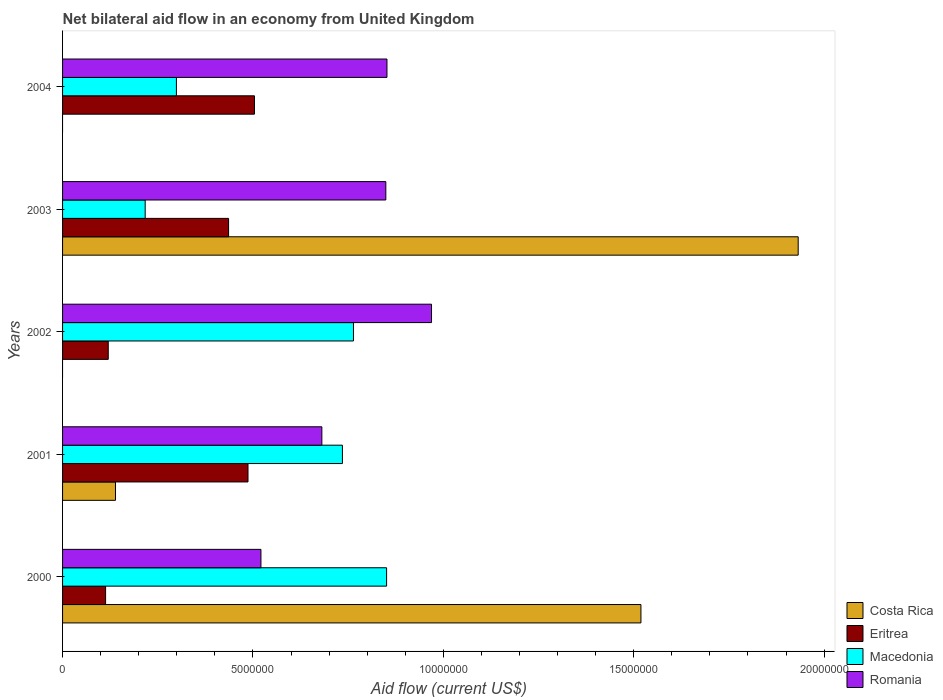How many different coloured bars are there?
Provide a succinct answer. 4. What is the net bilateral aid flow in Macedonia in 2000?
Your answer should be very brief. 8.51e+06. Across all years, what is the maximum net bilateral aid flow in Romania?
Your answer should be compact. 9.69e+06. Across all years, what is the minimum net bilateral aid flow in Eritrea?
Your response must be concise. 1.13e+06. What is the total net bilateral aid flow in Costa Rica in the graph?
Give a very brief answer. 3.59e+07. What is the difference between the net bilateral aid flow in Eritrea in 2002 and that in 2004?
Offer a very short reply. -3.84e+06. What is the difference between the net bilateral aid flow in Costa Rica in 2004 and the net bilateral aid flow in Macedonia in 2003?
Give a very brief answer. -2.17e+06. What is the average net bilateral aid flow in Macedonia per year?
Make the answer very short. 5.73e+06. In the year 2001, what is the difference between the net bilateral aid flow in Costa Rica and net bilateral aid flow in Eritrea?
Offer a very short reply. -3.48e+06. In how many years, is the net bilateral aid flow in Costa Rica greater than 16000000 US$?
Offer a very short reply. 1. What is the ratio of the net bilateral aid flow in Eritrea in 2000 to that in 2002?
Offer a terse response. 0.94. Is the difference between the net bilateral aid flow in Costa Rica in 2001 and 2003 greater than the difference between the net bilateral aid flow in Eritrea in 2001 and 2003?
Provide a succinct answer. No. What is the difference between the highest and the second highest net bilateral aid flow in Costa Rica?
Provide a succinct answer. 4.13e+06. What is the difference between the highest and the lowest net bilateral aid flow in Macedonia?
Your answer should be very brief. 6.34e+06. Is the sum of the net bilateral aid flow in Macedonia in 2002 and 2003 greater than the maximum net bilateral aid flow in Romania across all years?
Offer a terse response. Yes. Is it the case that in every year, the sum of the net bilateral aid flow in Costa Rica and net bilateral aid flow in Eritrea is greater than the sum of net bilateral aid flow in Macedonia and net bilateral aid flow in Romania?
Your answer should be very brief. No. Is it the case that in every year, the sum of the net bilateral aid flow in Romania and net bilateral aid flow in Costa Rica is greater than the net bilateral aid flow in Eritrea?
Your answer should be very brief. Yes. How many bars are there?
Make the answer very short. 18. How many years are there in the graph?
Your response must be concise. 5. Are the values on the major ticks of X-axis written in scientific E-notation?
Offer a terse response. No. Does the graph contain any zero values?
Ensure brevity in your answer.  Yes. Does the graph contain grids?
Provide a short and direct response. No. Where does the legend appear in the graph?
Make the answer very short. Bottom right. How many legend labels are there?
Make the answer very short. 4. How are the legend labels stacked?
Provide a succinct answer. Vertical. What is the title of the graph?
Give a very brief answer. Net bilateral aid flow in an economy from United Kingdom. Does "Senegal" appear as one of the legend labels in the graph?
Make the answer very short. No. What is the label or title of the X-axis?
Provide a short and direct response. Aid flow (current US$). What is the Aid flow (current US$) in Costa Rica in 2000?
Ensure brevity in your answer.  1.52e+07. What is the Aid flow (current US$) in Eritrea in 2000?
Your answer should be very brief. 1.13e+06. What is the Aid flow (current US$) in Macedonia in 2000?
Make the answer very short. 8.51e+06. What is the Aid flow (current US$) in Romania in 2000?
Ensure brevity in your answer.  5.21e+06. What is the Aid flow (current US$) of Costa Rica in 2001?
Ensure brevity in your answer.  1.39e+06. What is the Aid flow (current US$) in Eritrea in 2001?
Offer a very short reply. 4.87e+06. What is the Aid flow (current US$) of Macedonia in 2001?
Ensure brevity in your answer.  7.35e+06. What is the Aid flow (current US$) in Romania in 2001?
Offer a very short reply. 6.81e+06. What is the Aid flow (current US$) of Eritrea in 2002?
Give a very brief answer. 1.20e+06. What is the Aid flow (current US$) in Macedonia in 2002?
Your answer should be compact. 7.64e+06. What is the Aid flow (current US$) of Romania in 2002?
Make the answer very short. 9.69e+06. What is the Aid flow (current US$) in Costa Rica in 2003?
Keep it short and to the point. 1.93e+07. What is the Aid flow (current US$) of Eritrea in 2003?
Offer a terse response. 4.36e+06. What is the Aid flow (current US$) of Macedonia in 2003?
Your response must be concise. 2.17e+06. What is the Aid flow (current US$) of Romania in 2003?
Provide a succinct answer. 8.49e+06. What is the Aid flow (current US$) of Costa Rica in 2004?
Provide a succinct answer. 0. What is the Aid flow (current US$) of Eritrea in 2004?
Offer a very short reply. 5.04e+06. What is the Aid flow (current US$) of Macedonia in 2004?
Make the answer very short. 2.99e+06. What is the Aid flow (current US$) in Romania in 2004?
Provide a short and direct response. 8.52e+06. Across all years, what is the maximum Aid flow (current US$) in Costa Rica?
Offer a terse response. 1.93e+07. Across all years, what is the maximum Aid flow (current US$) of Eritrea?
Give a very brief answer. 5.04e+06. Across all years, what is the maximum Aid flow (current US$) in Macedonia?
Your answer should be very brief. 8.51e+06. Across all years, what is the maximum Aid flow (current US$) in Romania?
Offer a very short reply. 9.69e+06. Across all years, what is the minimum Aid flow (current US$) in Costa Rica?
Offer a terse response. 0. Across all years, what is the minimum Aid flow (current US$) of Eritrea?
Make the answer very short. 1.13e+06. Across all years, what is the minimum Aid flow (current US$) of Macedonia?
Your answer should be very brief. 2.17e+06. Across all years, what is the minimum Aid flow (current US$) in Romania?
Offer a terse response. 5.21e+06. What is the total Aid flow (current US$) in Costa Rica in the graph?
Offer a very short reply. 3.59e+07. What is the total Aid flow (current US$) in Eritrea in the graph?
Offer a very short reply. 1.66e+07. What is the total Aid flow (current US$) in Macedonia in the graph?
Provide a succinct answer. 2.87e+07. What is the total Aid flow (current US$) of Romania in the graph?
Offer a very short reply. 3.87e+07. What is the difference between the Aid flow (current US$) of Costa Rica in 2000 and that in 2001?
Offer a very short reply. 1.38e+07. What is the difference between the Aid flow (current US$) of Eritrea in 2000 and that in 2001?
Your response must be concise. -3.74e+06. What is the difference between the Aid flow (current US$) in Macedonia in 2000 and that in 2001?
Make the answer very short. 1.16e+06. What is the difference between the Aid flow (current US$) in Romania in 2000 and that in 2001?
Provide a short and direct response. -1.60e+06. What is the difference between the Aid flow (current US$) of Macedonia in 2000 and that in 2002?
Offer a terse response. 8.70e+05. What is the difference between the Aid flow (current US$) in Romania in 2000 and that in 2002?
Give a very brief answer. -4.48e+06. What is the difference between the Aid flow (current US$) of Costa Rica in 2000 and that in 2003?
Provide a short and direct response. -4.13e+06. What is the difference between the Aid flow (current US$) in Eritrea in 2000 and that in 2003?
Your answer should be very brief. -3.23e+06. What is the difference between the Aid flow (current US$) in Macedonia in 2000 and that in 2003?
Keep it short and to the point. 6.34e+06. What is the difference between the Aid flow (current US$) of Romania in 2000 and that in 2003?
Your answer should be very brief. -3.28e+06. What is the difference between the Aid flow (current US$) in Eritrea in 2000 and that in 2004?
Make the answer very short. -3.91e+06. What is the difference between the Aid flow (current US$) in Macedonia in 2000 and that in 2004?
Your answer should be compact. 5.52e+06. What is the difference between the Aid flow (current US$) in Romania in 2000 and that in 2004?
Offer a terse response. -3.31e+06. What is the difference between the Aid flow (current US$) in Eritrea in 2001 and that in 2002?
Keep it short and to the point. 3.67e+06. What is the difference between the Aid flow (current US$) of Macedonia in 2001 and that in 2002?
Make the answer very short. -2.90e+05. What is the difference between the Aid flow (current US$) in Romania in 2001 and that in 2002?
Offer a terse response. -2.88e+06. What is the difference between the Aid flow (current US$) of Costa Rica in 2001 and that in 2003?
Keep it short and to the point. -1.79e+07. What is the difference between the Aid flow (current US$) in Eritrea in 2001 and that in 2003?
Your response must be concise. 5.10e+05. What is the difference between the Aid flow (current US$) in Macedonia in 2001 and that in 2003?
Your answer should be very brief. 5.18e+06. What is the difference between the Aid flow (current US$) in Romania in 2001 and that in 2003?
Keep it short and to the point. -1.68e+06. What is the difference between the Aid flow (current US$) in Macedonia in 2001 and that in 2004?
Ensure brevity in your answer.  4.36e+06. What is the difference between the Aid flow (current US$) in Romania in 2001 and that in 2004?
Provide a succinct answer. -1.71e+06. What is the difference between the Aid flow (current US$) in Eritrea in 2002 and that in 2003?
Your answer should be very brief. -3.16e+06. What is the difference between the Aid flow (current US$) of Macedonia in 2002 and that in 2003?
Your answer should be compact. 5.47e+06. What is the difference between the Aid flow (current US$) in Romania in 2002 and that in 2003?
Your response must be concise. 1.20e+06. What is the difference between the Aid flow (current US$) of Eritrea in 2002 and that in 2004?
Your answer should be compact. -3.84e+06. What is the difference between the Aid flow (current US$) of Macedonia in 2002 and that in 2004?
Your answer should be very brief. 4.65e+06. What is the difference between the Aid flow (current US$) in Romania in 2002 and that in 2004?
Offer a very short reply. 1.17e+06. What is the difference between the Aid flow (current US$) of Eritrea in 2003 and that in 2004?
Your answer should be very brief. -6.80e+05. What is the difference between the Aid flow (current US$) of Macedonia in 2003 and that in 2004?
Provide a short and direct response. -8.20e+05. What is the difference between the Aid flow (current US$) of Romania in 2003 and that in 2004?
Keep it short and to the point. -3.00e+04. What is the difference between the Aid flow (current US$) of Costa Rica in 2000 and the Aid flow (current US$) of Eritrea in 2001?
Ensure brevity in your answer.  1.03e+07. What is the difference between the Aid flow (current US$) of Costa Rica in 2000 and the Aid flow (current US$) of Macedonia in 2001?
Give a very brief answer. 7.84e+06. What is the difference between the Aid flow (current US$) in Costa Rica in 2000 and the Aid flow (current US$) in Romania in 2001?
Your answer should be very brief. 8.38e+06. What is the difference between the Aid flow (current US$) of Eritrea in 2000 and the Aid flow (current US$) of Macedonia in 2001?
Ensure brevity in your answer.  -6.22e+06. What is the difference between the Aid flow (current US$) in Eritrea in 2000 and the Aid flow (current US$) in Romania in 2001?
Ensure brevity in your answer.  -5.68e+06. What is the difference between the Aid flow (current US$) of Macedonia in 2000 and the Aid flow (current US$) of Romania in 2001?
Make the answer very short. 1.70e+06. What is the difference between the Aid flow (current US$) of Costa Rica in 2000 and the Aid flow (current US$) of Eritrea in 2002?
Make the answer very short. 1.40e+07. What is the difference between the Aid flow (current US$) in Costa Rica in 2000 and the Aid flow (current US$) in Macedonia in 2002?
Provide a succinct answer. 7.55e+06. What is the difference between the Aid flow (current US$) in Costa Rica in 2000 and the Aid flow (current US$) in Romania in 2002?
Provide a succinct answer. 5.50e+06. What is the difference between the Aid flow (current US$) of Eritrea in 2000 and the Aid flow (current US$) of Macedonia in 2002?
Provide a short and direct response. -6.51e+06. What is the difference between the Aid flow (current US$) in Eritrea in 2000 and the Aid flow (current US$) in Romania in 2002?
Ensure brevity in your answer.  -8.56e+06. What is the difference between the Aid flow (current US$) of Macedonia in 2000 and the Aid flow (current US$) of Romania in 2002?
Your response must be concise. -1.18e+06. What is the difference between the Aid flow (current US$) of Costa Rica in 2000 and the Aid flow (current US$) of Eritrea in 2003?
Your response must be concise. 1.08e+07. What is the difference between the Aid flow (current US$) in Costa Rica in 2000 and the Aid flow (current US$) in Macedonia in 2003?
Your response must be concise. 1.30e+07. What is the difference between the Aid flow (current US$) of Costa Rica in 2000 and the Aid flow (current US$) of Romania in 2003?
Keep it short and to the point. 6.70e+06. What is the difference between the Aid flow (current US$) of Eritrea in 2000 and the Aid flow (current US$) of Macedonia in 2003?
Provide a succinct answer. -1.04e+06. What is the difference between the Aid flow (current US$) of Eritrea in 2000 and the Aid flow (current US$) of Romania in 2003?
Make the answer very short. -7.36e+06. What is the difference between the Aid flow (current US$) in Costa Rica in 2000 and the Aid flow (current US$) in Eritrea in 2004?
Offer a very short reply. 1.02e+07. What is the difference between the Aid flow (current US$) in Costa Rica in 2000 and the Aid flow (current US$) in Macedonia in 2004?
Provide a short and direct response. 1.22e+07. What is the difference between the Aid flow (current US$) in Costa Rica in 2000 and the Aid flow (current US$) in Romania in 2004?
Provide a succinct answer. 6.67e+06. What is the difference between the Aid flow (current US$) in Eritrea in 2000 and the Aid flow (current US$) in Macedonia in 2004?
Your answer should be very brief. -1.86e+06. What is the difference between the Aid flow (current US$) of Eritrea in 2000 and the Aid flow (current US$) of Romania in 2004?
Provide a short and direct response. -7.39e+06. What is the difference between the Aid flow (current US$) of Costa Rica in 2001 and the Aid flow (current US$) of Eritrea in 2002?
Make the answer very short. 1.90e+05. What is the difference between the Aid flow (current US$) in Costa Rica in 2001 and the Aid flow (current US$) in Macedonia in 2002?
Make the answer very short. -6.25e+06. What is the difference between the Aid flow (current US$) in Costa Rica in 2001 and the Aid flow (current US$) in Romania in 2002?
Ensure brevity in your answer.  -8.30e+06. What is the difference between the Aid flow (current US$) of Eritrea in 2001 and the Aid flow (current US$) of Macedonia in 2002?
Give a very brief answer. -2.77e+06. What is the difference between the Aid flow (current US$) in Eritrea in 2001 and the Aid flow (current US$) in Romania in 2002?
Offer a very short reply. -4.82e+06. What is the difference between the Aid flow (current US$) in Macedonia in 2001 and the Aid flow (current US$) in Romania in 2002?
Offer a very short reply. -2.34e+06. What is the difference between the Aid flow (current US$) of Costa Rica in 2001 and the Aid flow (current US$) of Eritrea in 2003?
Make the answer very short. -2.97e+06. What is the difference between the Aid flow (current US$) of Costa Rica in 2001 and the Aid flow (current US$) of Macedonia in 2003?
Keep it short and to the point. -7.80e+05. What is the difference between the Aid flow (current US$) in Costa Rica in 2001 and the Aid flow (current US$) in Romania in 2003?
Ensure brevity in your answer.  -7.10e+06. What is the difference between the Aid flow (current US$) in Eritrea in 2001 and the Aid flow (current US$) in Macedonia in 2003?
Ensure brevity in your answer.  2.70e+06. What is the difference between the Aid flow (current US$) in Eritrea in 2001 and the Aid flow (current US$) in Romania in 2003?
Ensure brevity in your answer.  -3.62e+06. What is the difference between the Aid flow (current US$) of Macedonia in 2001 and the Aid flow (current US$) of Romania in 2003?
Your answer should be compact. -1.14e+06. What is the difference between the Aid flow (current US$) in Costa Rica in 2001 and the Aid flow (current US$) in Eritrea in 2004?
Give a very brief answer. -3.65e+06. What is the difference between the Aid flow (current US$) of Costa Rica in 2001 and the Aid flow (current US$) of Macedonia in 2004?
Make the answer very short. -1.60e+06. What is the difference between the Aid flow (current US$) of Costa Rica in 2001 and the Aid flow (current US$) of Romania in 2004?
Your answer should be very brief. -7.13e+06. What is the difference between the Aid flow (current US$) in Eritrea in 2001 and the Aid flow (current US$) in Macedonia in 2004?
Your answer should be compact. 1.88e+06. What is the difference between the Aid flow (current US$) in Eritrea in 2001 and the Aid flow (current US$) in Romania in 2004?
Your answer should be very brief. -3.65e+06. What is the difference between the Aid flow (current US$) of Macedonia in 2001 and the Aid flow (current US$) of Romania in 2004?
Offer a terse response. -1.17e+06. What is the difference between the Aid flow (current US$) of Eritrea in 2002 and the Aid flow (current US$) of Macedonia in 2003?
Ensure brevity in your answer.  -9.70e+05. What is the difference between the Aid flow (current US$) in Eritrea in 2002 and the Aid flow (current US$) in Romania in 2003?
Offer a very short reply. -7.29e+06. What is the difference between the Aid flow (current US$) of Macedonia in 2002 and the Aid flow (current US$) of Romania in 2003?
Your answer should be compact. -8.50e+05. What is the difference between the Aid flow (current US$) of Eritrea in 2002 and the Aid flow (current US$) of Macedonia in 2004?
Offer a terse response. -1.79e+06. What is the difference between the Aid flow (current US$) in Eritrea in 2002 and the Aid flow (current US$) in Romania in 2004?
Your answer should be compact. -7.32e+06. What is the difference between the Aid flow (current US$) of Macedonia in 2002 and the Aid flow (current US$) of Romania in 2004?
Offer a very short reply. -8.80e+05. What is the difference between the Aid flow (current US$) in Costa Rica in 2003 and the Aid flow (current US$) in Eritrea in 2004?
Make the answer very short. 1.43e+07. What is the difference between the Aid flow (current US$) of Costa Rica in 2003 and the Aid flow (current US$) of Macedonia in 2004?
Your answer should be compact. 1.63e+07. What is the difference between the Aid flow (current US$) of Costa Rica in 2003 and the Aid flow (current US$) of Romania in 2004?
Provide a succinct answer. 1.08e+07. What is the difference between the Aid flow (current US$) of Eritrea in 2003 and the Aid flow (current US$) of Macedonia in 2004?
Your answer should be very brief. 1.37e+06. What is the difference between the Aid flow (current US$) of Eritrea in 2003 and the Aid flow (current US$) of Romania in 2004?
Offer a terse response. -4.16e+06. What is the difference between the Aid flow (current US$) in Macedonia in 2003 and the Aid flow (current US$) in Romania in 2004?
Provide a short and direct response. -6.35e+06. What is the average Aid flow (current US$) of Costa Rica per year?
Ensure brevity in your answer.  7.18e+06. What is the average Aid flow (current US$) in Eritrea per year?
Ensure brevity in your answer.  3.32e+06. What is the average Aid flow (current US$) in Macedonia per year?
Your response must be concise. 5.73e+06. What is the average Aid flow (current US$) in Romania per year?
Offer a very short reply. 7.74e+06. In the year 2000, what is the difference between the Aid flow (current US$) of Costa Rica and Aid flow (current US$) of Eritrea?
Offer a terse response. 1.41e+07. In the year 2000, what is the difference between the Aid flow (current US$) of Costa Rica and Aid flow (current US$) of Macedonia?
Offer a terse response. 6.68e+06. In the year 2000, what is the difference between the Aid flow (current US$) of Costa Rica and Aid flow (current US$) of Romania?
Keep it short and to the point. 9.98e+06. In the year 2000, what is the difference between the Aid flow (current US$) of Eritrea and Aid flow (current US$) of Macedonia?
Give a very brief answer. -7.38e+06. In the year 2000, what is the difference between the Aid flow (current US$) in Eritrea and Aid flow (current US$) in Romania?
Offer a terse response. -4.08e+06. In the year 2000, what is the difference between the Aid flow (current US$) of Macedonia and Aid flow (current US$) of Romania?
Your response must be concise. 3.30e+06. In the year 2001, what is the difference between the Aid flow (current US$) of Costa Rica and Aid flow (current US$) of Eritrea?
Offer a very short reply. -3.48e+06. In the year 2001, what is the difference between the Aid flow (current US$) of Costa Rica and Aid flow (current US$) of Macedonia?
Your answer should be very brief. -5.96e+06. In the year 2001, what is the difference between the Aid flow (current US$) in Costa Rica and Aid flow (current US$) in Romania?
Your answer should be compact. -5.42e+06. In the year 2001, what is the difference between the Aid flow (current US$) of Eritrea and Aid flow (current US$) of Macedonia?
Offer a terse response. -2.48e+06. In the year 2001, what is the difference between the Aid flow (current US$) in Eritrea and Aid flow (current US$) in Romania?
Keep it short and to the point. -1.94e+06. In the year 2001, what is the difference between the Aid flow (current US$) of Macedonia and Aid flow (current US$) of Romania?
Your response must be concise. 5.40e+05. In the year 2002, what is the difference between the Aid flow (current US$) of Eritrea and Aid flow (current US$) of Macedonia?
Ensure brevity in your answer.  -6.44e+06. In the year 2002, what is the difference between the Aid flow (current US$) of Eritrea and Aid flow (current US$) of Romania?
Keep it short and to the point. -8.49e+06. In the year 2002, what is the difference between the Aid flow (current US$) in Macedonia and Aid flow (current US$) in Romania?
Keep it short and to the point. -2.05e+06. In the year 2003, what is the difference between the Aid flow (current US$) in Costa Rica and Aid flow (current US$) in Eritrea?
Provide a succinct answer. 1.50e+07. In the year 2003, what is the difference between the Aid flow (current US$) of Costa Rica and Aid flow (current US$) of Macedonia?
Your answer should be very brief. 1.72e+07. In the year 2003, what is the difference between the Aid flow (current US$) of Costa Rica and Aid flow (current US$) of Romania?
Make the answer very short. 1.08e+07. In the year 2003, what is the difference between the Aid flow (current US$) in Eritrea and Aid flow (current US$) in Macedonia?
Your response must be concise. 2.19e+06. In the year 2003, what is the difference between the Aid flow (current US$) of Eritrea and Aid flow (current US$) of Romania?
Your response must be concise. -4.13e+06. In the year 2003, what is the difference between the Aid flow (current US$) in Macedonia and Aid flow (current US$) in Romania?
Ensure brevity in your answer.  -6.32e+06. In the year 2004, what is the difference between the Aid flow (current US$) in Eritrea and Aid flow (current US$) in Macedonia?
Give a very brief answer. 2.05e+06. In the year 2004, what is the difference between the Aid flow (current US$) in Eritrea and Aid flow (current US$) in Romania?
Offer a very short reply. -3.48e+06. In the year 2004, what is the difference between the Aid flow (current US$) of Macedonia and Aid flow (current US$) of Romania?
Offer a very short reply. -5.53e+06. What is the ratio of the Aid flow (current US$) in Costa Rica in 2000 to that in 2001?
Ensure brevity in your answer.  10.93. What is the ratio of the Aid flow (current US$) in Eritrea in 2000 to that in 2001?
Give a very brief answer. 0.23. What is the ratio of the Aid flow (current US$) of Macedonia in 2000 to that in 2001?
Your answer should be very brief. 1.16. What is the ratio of the Aid flow (current US$) of Romania in 2000 to that in 2001?
Give a very brief answer. 0.77. What is the ratio of the Aid flow (current US$) of Eritrea in 2000 to that in 2002?
Offer a terse response. 0.94. What is the ratio of the Aid flow (current US$) of Macedonia in 2000 to that in 2002?
Offer a very short reply. 1.11. What is the ratio of the Aid flow (current US$) in Romania in 2000 to that in 2002?
Provide a succinct answer. 0.54. What is the ratio of the Aid flow (current US$) in Costa Rica in 2000 to that in 2003?
Keep it short and to the point. 0.79. What is the ratio of the Aid flow (current US$) of Eritrea in 2000 to that in 2003?
Give a very brief answer. 0.26. What is the ratio of the Aid flow (current US$) of Macedonia in 2000 to that in 2003?
Your answer should be compact. 3.92. What is the ratio of the Aid flow (current US$) in Romania in 2000 to that in 2003?
Offer a very short reply. 0.61. What is the ratio of the Aid flow (current US$) of Eritrea in 2000 to that in 2004?
Give a very brief answer. 0.22. What is the ratio of the Aid flow (current US$) in Macedonia in 2000 to that in 2004?
Give a very brief answer. 2.85. What is the ratio of the Aid flow (current US$) in Romania in 2000 to that in 2004?
Your answer should be compact. 0.61. What is the ratio of the Aid flow (current US$) in Eritrea in 2001 to that in 2002?
Offer a very short reply. 4.06. What is the ratio of the Aid flow (current US$) in Romania in 2001 to that in 2002?
Ensure brevity in your answer.  0.7. What is the ratio of the Aid flow (current US$) in Costa Rica in 2001 to that in 2003?
Provide a short and direct response. 0.07. What is the ratio of the Aid flow (current US$) of Eritrea in 2001 to that in 2003?
Your answer should be very brief. 1.12. What is the ratio of the Aid flow (current US$) in Macedonia in 2001 to that in 2003?
Provide a succinct answer. 3.39. What is the ratio of the Aid flow (current US$) of Romania in 2001 to that in 2003?
Keep it short and to the point. 0.8. What is the ratio of the Aid flow (current US$) in Eritrea in 2001 to that in 2004?
Ensure brevity in your answer.  0.97. What is the ratio of the Aid flow (current US$) of Macedonia in 2001 to that in 2004?
Ensure brevity in your answer.  2.46. What is the ratio of the Aid flow (current US$) in Romania in 2001 to that in 2004?
Your answer should be compact. 0.8. What is the ratio of the Aid flow (current US$) of Eritrea in 2002 to that in 2003?
Provide a succinct answer. 0.28. What is the ratio of the Aid flow (current US$) of Macedonia in 2002 to that in 2003?
Your response must be concise. 3.52. What is the ratio of the Aid flow (current US$) in Romania in 2002 to that in 2003?
Offer a terse response. 1.14. What is the ratio of the Aid flow (current US$) in Eritrea in 2002 to that in 2004?
Offer a terse response. 0.24. What is the ratio of the Aid flow (current US$) in Macedonia in 2002 to that in 2004?
Make the answer very short. 2.56. What is the ratio of the Aid flow (current US$) in Romania in 2002 to that in 2004?
Your response must be concise. 1.14. What is the ratio of the Aid flow (current US$) of Eritrea in 2003 to that in 2004?
Provide a short and direct response. 0.87. What is the ratio of the Aid flow (current US$) in Macedonia in 2003 to that in 2004?
Ensure brevity in your answer.  0.73. What is the difference between the highest and the second highest Aid flow (current US$) in Costa Rica?
Keep it short and to the point. 4.13e+06. What is the difference between the highest and the second highest Aid flow (current US$) of Eritrea?
Make the answer very short. 1.70e+05. What is the difference between the highest and the second highest Aid flow (current US$) in Macedonia?
Give a very brief answer. 8.70e+05. What is the difference between the highest and the second highest Aid flow (current US$) in Romania?
Give a very brief answer. 1.17e+06. What is the difference between the highest and the lowest Aid flow (current US$) of Costa Rica?
Make the answer very short. 1.93e+07. What is the difference between the highest and the lowest Aid flow (current US$) of Eritrea?
Your answer should be very brief. 3.91e+06. What is the difference between the highest and the lowest Aid flow (current US$) of Macedonia?
Offer a terse response. 6.34e+06. What is the difference between the highest and the lowest Aid flow (current US$) in Romania?
Your answer should be very brief. 4.48e+06. 